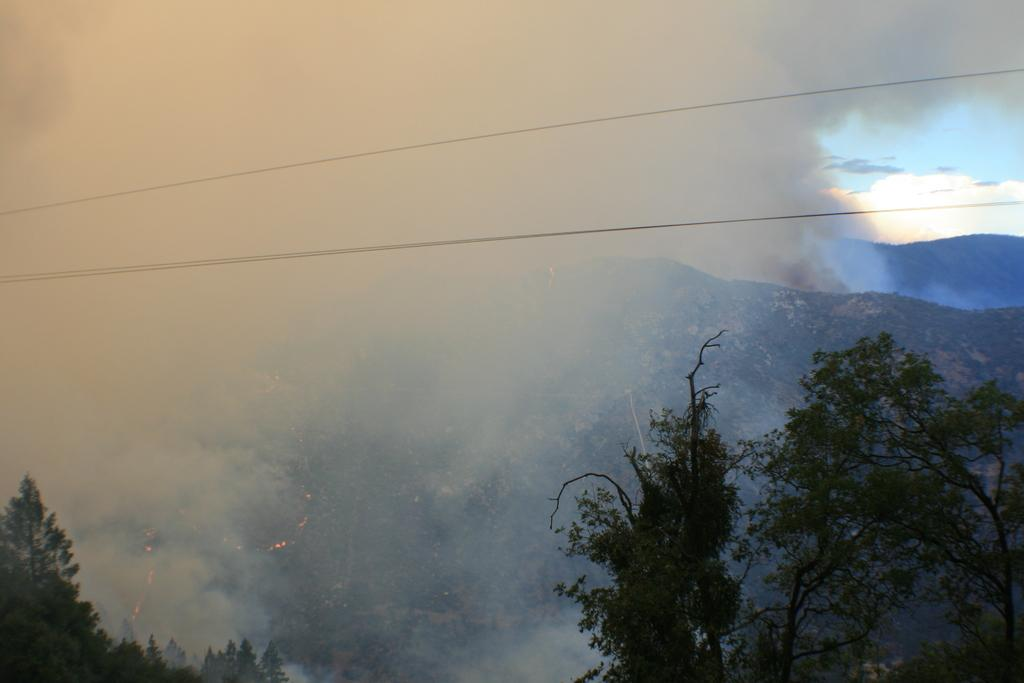What can be seen in the foreground of the image? There are trees in front of the image. What is present in the image that might indicate human activity? There are wires in the image. What can be seen in the background of the image? There are mountains visible in the background, and the sky is also visible. What might be the source of the smoke in the image? The source of the smoke is not explicitly mentioned in the facts, but it could be related to human activity or a natural occurrence. Can you describe the engine that is visible in the image? There is no engine present in the image. What type of scene is depicted in the image? The image does not depict a specific scene; it shows trees, wires, smoke, mountains, and the sky. 